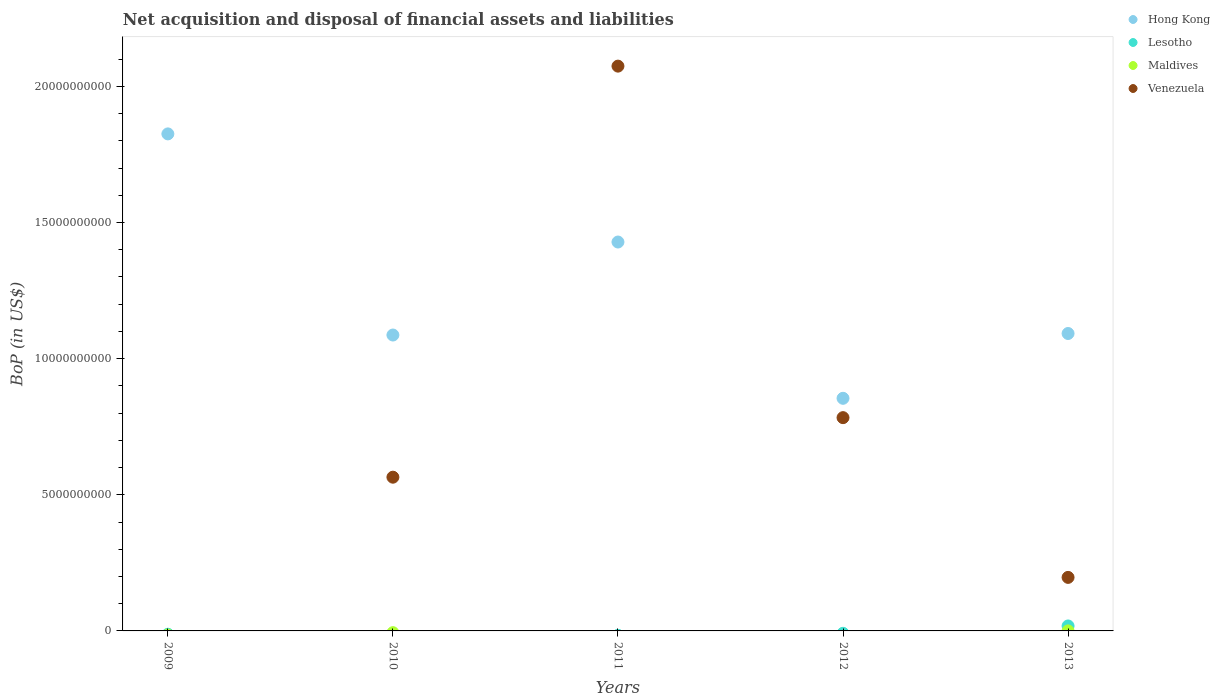Is the number of dotlines equal to the number of legend labels?
Your response must be concise. No. What is the Balance of Payments in Maldives in 2013?
Offer a terse response. 1.18e+06. Across all years, what is the maximum Balance of Payments in Lesotho?
Your response must be concise. 1.82e+08. Across all years, what is the minimum Balance of Payments in Hong Kong?
Ensure brevity in your answer.  8.54e+09. What is the total Balance of Payments in Lesotho in the graph?
Your response must be concise. 1.82e+08. What is the difference between the Balance of Payments in Hong Kong in 2010 and that in 2013?
Your answer should be very brief. -5.62e+07. What is the difference between the Balance of Payments in Hong Kong in 2011 and the Balance of Payments in Maldives in 2009?
Give a very brief answer. 1.43e+1. What is the average Balance of Payments in Venezuela per year?
Provide a short and direct response. 7.24e+09. In the year 2012, what is the difference between the Balance of Payments in Hong Kong and Balance of Payments in Venezuela?
Provide a short and direct response. 7.10e+08. What is the ratio of the Balance of Payments in Venezuela in 2011 to that in 2013?
Give a very brief answer. 10.55. Is the difference between the Balance of Payments in Hong Kong in 2010 and 2011 greater than the difference between the Balance of Payments in Venezuela in 2010 and 2011?
Offer a very short reply. Yes. What is the difference between the highest and the second highest Balance of Payments in Venezuela?
Your response must be concise. 1.29e+1. What is the difference between the highest and the lowest Balance of Payments in Maldives?
Your response must be concise. 1.18e+06. Is the sum of the Balance of Payments in Hong Kong in 2009 and 2011 greater than the maximum Balance of Payments in Venezuela across all years?
Provide a succinct answer. Yes. Is it the case that in every year, the sum of the Balance of Payments in Venezuela and Balance of Payments in Lesotho  is greater than the sum of Balance of Payments in Maldives and Balance of Payments in Hong Kong?
Give a very brief answer. No. Does the Balance of Payments in Maldives monotonically increase over the years?
Offer a terse response. No. Is the Balance of Payments in Maldives strictly greater than the Balance of Payments in Hong Kong over the years?
Give a very brief answer. No. How many dotlines are there?
Ensure brevity in your answer.  4. How many years are there in the graph?
Offer a terse response. 5. What is the difference between two consecutive major ticks on the Y-axis?
Your answer should be very brief. 5.00e+09. Are the values on the major ticks of Y-axis written in scientific E-notation?
Offer a very short reply. No. Does the graph contain any zero values?
Provide a short and direct response. Yes. Does the graph contain grids?
Your response must be concise. No. Where does the legend appear in the graph?
Provide a short and direct response. Top right. How are the legend labels stacked?
Keep it short and to the point. Vertical. What is the title of the graph?
Your answer should be compact. Net acquisition and disposal of financial assets and liabilities. What is the label or title of the Y-axis?
Ensure brevity in your answer.  BoP (in US$). What is the BoP (in US$) in Hong Kong in 2009?
Your response must be concise. 1.83e+1. What is the BoP (in US$) in Maldives in 2009?
Provide a short and direct response. 0. What is the BoP (in US$) of Venezuela in 2009?
Your answer should be compact. 0. What is the BoP (in US$) in Hong Kong in 2010?
Offer a very short reply. 1.09e+1. What is the BoP (in US$) of Lesotho in 2010?
Provide a succinct answer. 0. What is the BoP (in US$) in Venezuela in 2010?
Provide a succinct answer. 5.65e+09. What is the BoP (in US$) in Hong Kong in 2011?
Give a very brief answer. 1.43e+1. What is the BoP (in US$) in Lesotho in 2011?
Provide a short and direct response. 0. What is the BoP (in US$) in Maldives in 2011?
Offer a very short reply. 0. What is the BoP (in US$) in Venezuela in 2011?
Your answer should be very brief. 2.07e+1. What is the BoP (in US$) of Hong Kong in 2012?
Ensure brevity in your answer.  8.54e+09. What is the BoP (in US$) in Lesotho in 2012?
Your answer should be very brief. 0. What is the BoP (in US$) in Maldives in 2012?
Your response must be concise. 0. What is the BoP (in US$) in Venezuela in 2012?
Ensure brevity in your answer.  7.83e+09. What is the BoP (in US$) in Hong Kong in 2013?
Give a very brief answer. 1.09e+1. What is the BoP (in US$) in Lesotho in 2013?
Your answer should be compact. 1.82e+08. What is the BoP (in US$) of Maldives in 2013?
Offer a very short reply. 1.18e+06. What is the BoP (in US$) of Venezuela in 2013?
Offer a very short reply. 1.97e+09. Across all years, what is the maximum BoP (in US$) in Hong Kong?
Your answer should be very brief. 1.83e+1. Across all years, what is the maximum BoP (in US$) of Lesotho?
Make the answer very short. 1.82e+08. Across all years, what is the maximum BoP (in US$) in Maldives?
Your answer should be compact. 1.18e+06. Across all years, what is the maximum BoP (in US$) of Venezuela?
Ensure brevity in your answer.  2.07e+1. Across all years, what is the minimum BoP (in US$) in Hong Kong?
Your answer should be very brief. 8.54e+09. Across all years, what is the minimum BoP (in US$) in Lesotho?
Provide a succinct answer. 0. Across all years, what is the minimum BoP (in US$) in Maldives?
Provide a short and direct response. 0. What is the total BoP (in US$) in Hong Kong in the graph?
Provide a succinct answer. 6.29e+1. What is the total BoP (in US$) in Lesotho in the graph?
Keep it short and to the point. 1.82e+08. What is the total BoP (in US$) in Maldives in the graph?
Make the answer very short. 1.18e+06. What is the total BoP (in US$) of Venezuela in the graph?
Ensure brevity in your answer.  3.62e+1. What is the difference between the BoP (in US$) of Hong Kong in 2009 and that in 2010?
Keep it short and to the point. 7.39e+09. What is the difference between the BoP (in US$) of Hong Kong in 2009 and that in 2011?
Offer a very short reply. 3.97e+09. What is the difference between the BoP (in US$) in Hong Kong in 2009 and that in 2012?
Your answer should be very brief. 9.71e+09. What is the difference between the BoP (in US$) in Hong Kong in 2009 and that in 2013?
Keep it short and to the point. 7.33e+09. What is the difference between the BoP (in US$) in Hong Kong in 2010 and that in 2011?
Your response must be concise. -3.42e+09. What is the difference between the BoP (in US$) of Venezuela in 2010 and that in 2011?
Your answer should be compact. -1.51e+1. What is the difference between the BoP (in US$) in Hong Kong in 2010 and that in 2012?
Your answer should be compact. 2.32e+09. What is the difference between the BoP (in US$) of Venezuela in 2010 and that in 2012?
Provide a short and direct response. -2.19e+09. What is the difference between the BoP (in US$) in Hong Kong in 2010 and that in 2013?
Make the answer very short. -5.62e+07. What is the difference between the BoP (in US$) in Venezuela in 2010 and that in 2013?
Make the answer very short. 3.68e+09. What is the difference between the BoP (in US$) in Hong Kong in 2011 and that in 2012?
Give a very brief answer. 5.74e+09. What is the difference between the BoP (in US$) of Venezuela in 2011 and that in 2012?
Keep it short and to the point. 1.29e+1. What is the difference between the BoP (in US$) in Hong Kong in 2011 and that in 2013?
Ensure brevity in your answer.  3.36e+09. What is the difference between the BoP (in US$) of Venezuela in 2011 and that in 2013?
Offer a terse response. 1.88e+1. What is the difference between the BoP (in US$) of Hong Kong in 2012 and that in 2013?
Your answer should be very brief. -2.38e+09. What is the difference between the BoP (in US$) in Venezuela in 2012 and that in 2013?
Offer a very short reply. 5.87e+09. What is the difference between the BoP (in US$) of Hong Kong in 2009 and the BoP (in US$) of Venezuela in 2010?
Provide a succinct answer. 1.26e+1. What is the difference between the BoP (in US$) in Hong Kong in 2009 and the BoP (in US$) in Venezuela in 2011?
Your answer should be very brief. -2.49e+09. What is the difference between the BoP (in US$) in Hong Kong in 2009 and the BoP (in US$) in Venezuela in 2012?
Your answer should be very brief. 1.04e+1. What is the difference between the BoP (in US$) of Hong Kong in 2009 and the BoP (in US$) of Lesotho in 2013?
Ensure brevity in your answer.  1.81e+1. What is the difference between the BoP (in US$) of Hong Kong in 2009 and the BoP (in US$) of Maldives in 2013?
Make the answer very short. 1.83e+1. What is the difference between the BoP (in US$) in Hong Kong in 2009 and the BoP (in US$) in Venezuela in 2013?
Ensure brevity in your answer.  1.63e+1. What is the difference between the BoP (in US$) in Hong Kong in 2010 and the BoP (in US$) in Venezuela in 2011?
Keep it short and to the point. -9.88e+09. What is the difference between the BoP (in US$) in Hong Kong in 2010 and the BoP (in US$) in Venezuela in 2012?
Your answer should be very brief. 3.03e+09. What is the difference between the BoP (in US$) in Hong Kong in 2010 and the BoP (in US$) in Lesotho in 2013?
Keep it short and to the point. 1.07e+1. What is the difference between the BoP (in US$) of Hong Kong in 2010 and the BoP (in US$) of Maldives in 2013?
Make the answer very short. 1.09e+1. What is the difference between the BoP (in US$) in Hong Kong in 2010 and the BoP (in US$) in Venezuela in 2013?
Offer a terse response. 8.90e+09. What is the difference between the BoP (in US$) in Hong Kong in 2011 and the BoP (in US$) in Venezuela in 2012?
Keep it short and to the point. 6.45e+09. What is the difference between the BoP (in US$) in Hong Kong in 2011 and the BoP (in US$) in Lesotho in 2013?
Offer a terse response. 1.41e+1. What is the difference between the BoP (in US$) of Hong Kong in 2011 and the BoP (in US$) of Maldives in 2013?
Keep it short and to the point. 1.43e+1. What is the difference between the BoP (in US$) in Hong Kong in 2011 and the BoP (in US$) in Venezuela in 2013?
Give a very brief answer. 1.23e+1. What is the difference between the BoP (in US$) in Hong Kong in 2012 and the BoP (in US$) in Lesotho in 2013?
Your answer should be compact. 8.36e+09. What is the difference between the BoP (in US$) of Hong Kong in 2012 and the BoP (in US$) of Maldives in 2013?
Give a very brief answer. 8.54e+09. What is the difference between the BoP (in US$) of Hong Kong in 2012 and the BoP (in US$) of Venezuela in 2013?
Your answer should be compact. 6.58e+09. What is the average BoP (in US$) of Hong Kong per year?
Ensure brevity in your answer.  1.26e+1. What is the average BoP (in US$) in Lesotho per year?
Your answer should be compact. 3.65e+07. What is the average BoP (in US$) in Maldives per year?
Your answer should be compact. 2.37e+05. What is the average BoP (in US$) of Venezuela per year?
Make the answer very short. 7.24e+09. In the year 2010, what is the difference between the BoP (in US$) of Hong Kong and BoP (in US$) of Venezuela?
Keep it short and to the point. 5.22e+09. In the year 2011, what is the difference between the BoP (in US$) in Hong Kong and BoP (in US$) in Venezuela?
Provide a succinct answer. -6.46e+09. In the year 2012, what is the difference between the BoP (in US$) in Hong Kong and BoP (in US$) in Venezuela?
Offer a terse response. 7.10e+08. In the year 2013, what is the difference between the BoP (in US$) in Hong Kong and BoP (in US$) in Lesotho?
Give a very brief answer. 1.07e+1. In the year 2013, what is the difference between the BoP (in US$) in Hong Kong and BoP (in US$) in Maldives?
Offer a terse response. 1.09e+1. In the year 2013, what is the difference between the BoP (in US$) in Hong Kong and BoP (in US$) in Venezuela?
Keep it short and to the point. 8.96e+09. In the year 2013, what is the difference between the BoP (in US$) in Lesotho and BoP (in US$) in Maldives?
Give a very brief answer. 1.81e+08. In the year 2013, what is the difference between the BoP (in US$) of Lesotho and BoP (in US$) of Venezuela?
Give a very brief answer. -1.78e+09. In the year 2013, what is the difference between the BoP (in US$) in Maldives and BoP (in US$) in Venezuela?
Ensure brevity in your answer.  -1.96e+09. What is the ratio of the BoP (in US$) in Hong Kong in 2009 to that in 2010?
Ensure brevity in your answer.  1.68. What is the ratio of the BoP (in US$) in Hong Kong in 2009 to that in 2011?
Your response must be concise. 1.28. What is the ratio of the BoP (in US$) in Hong Kong in 2009 to that in 2012?
Keep it short and to the point. 2.14. What is the ratio of the BoP (in US$) in Hong Kong in 2009 to that in 2013?
Make the answer very short. 1.67. What is the ratio of the BoP (in US$) in Hong Kong in 2010 to that in 2011?
Make the answer very short. 0.76. What is the ratio of the BoP (in US$) of Venezuela in 2010 to that in 2011?
Your answer should be very brief. 0.27. What is the ratio of the BoP (in US$) of Hong Kong in 2010 to that in 2012?
Your answer should be compact. 1.27. What is the ratio of the BoP (in US$) in Venezuela in 2010 to that in 2012?
Keep it short and to the point. 0.72. What is the ratio of the BoP (in US$) of Hong Kong in 2010 to that in 2013?
Keep it short and to the point. 0.99. What is the ratio of the BoP (in US$) of Venezuela in 2010 to that in 2013?
Make the answer very short. 2.87. What is the ratio of the BoP (in US$) in Hong Kong in 2011 to that in 2012?
Provide a short and direct response. 1.67. What is the ratio of the BoP (in US$) in Venezuela in 2011 to that in 2012?
Your response must be concise. 2.65. What is the ratio of the BoP (in US$) of Hong Kong in 2011 to that in 2013?
Keep it short and to the point. 1.31. What is the ratio of the BoP (in US$) of Venezuela in 2011 to that in 2013?
Offer a terse response. 10.55. What is the ratio of the BoP (in US$) in Hong Kong in 2012 to that in 2013?
Provide a short and direct response. 0.78. What is the ratio of the BoP (in US$) of Venezuela in 2012 to that in 2013?
Keep it short and to the point. 3.98. What is the difference between the highest and the second highest BoP (in US$) of Hong Kong?
Your response must be concise. 3.97e+09. What is the difference between the highest and the second highest BoP (in US$) of Venezuela?
Provide a short and direct response. 1.29e+1. What is the difference between the highest and the lowest BoP (in US$) of Hong Kong?
Offer a terse response. 9.71e+09. What is the difference between the highest and the lowest BoP (in US$) of Lesotho?
Your answer should be compact. 1.82e+08. What is the difference between the highest and the lowest BoP (in US$) of Maldives?
Offer a very short reply. 1.18e+06. What is the difference between the highest and the lowest BoP (in US$) of Venezuela?
Provide a succinct answer. 2.07e+1. 